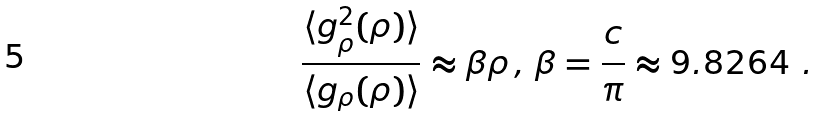Convert formula to latex. <formula><loc_0><loc_0><loc_500><loc_500>\frac { \langle g ^ { 2 } _ { \rho } ( \rho ) \rangle } { \langle g _ { \rho } ( \rho ) \rangle } \approx \beta \rho \, , \, \beta = \frac { c } { \pi } \approx 9 . 8 2 6 4 \ .</formula> 